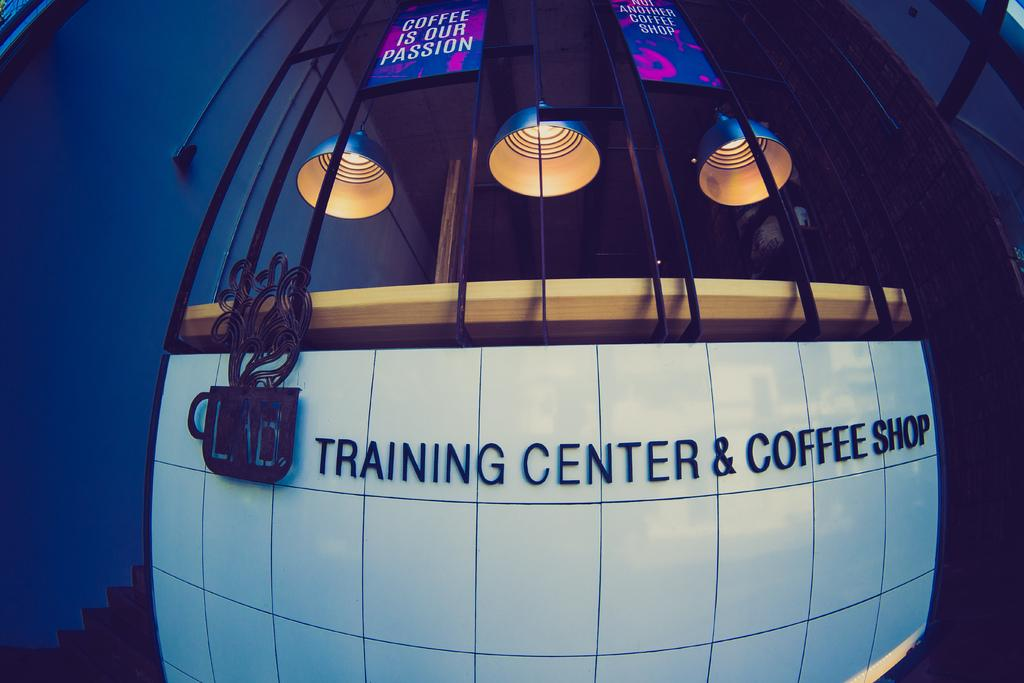<image>
Write a terse but informative summary of the picture. Words on a white wall that say "Training Center & Coffee Shop". 